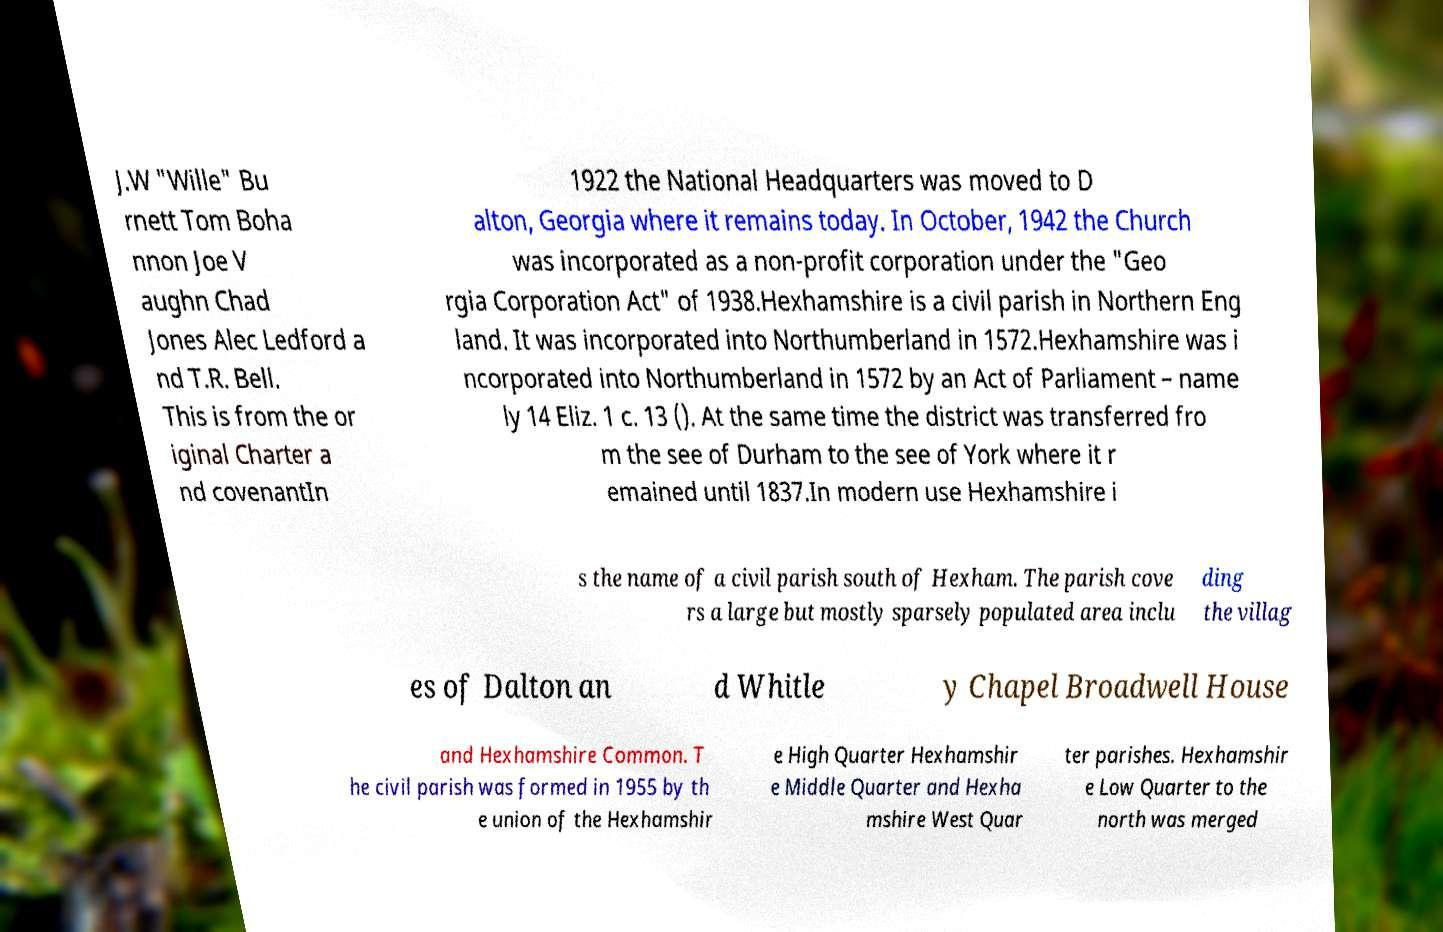Can you read and provide the text displayed in the image?This photo seems to have some interesting text. Can you extract and type it out for me? J.W "Wille" Bu rnett Tom Boha nnon Joe V aughn Chad Jones Alec Ledford a nd T.R. Bell. This is from the or iginal Charter a nd covenantIn 1922 the National Headquarters was moved to D alton, Georgia where it remains today. In October, 1942 the Church was incorporated as a non-profit corporation under the "Geo rgia Corporation Act" of 1938.Hexhamshire is a civil parish in Northern Eng land. It was incorporated into Northumberland in 1572.Hexhamshire was i ncorporated into Northumberland in 1572 by an Act of Parliament – name ly 14 Eliz. 1 c. 13 (). At the same time the district was transferred fro m the see of Durham to the see of York where it r emained until 1837.In modern use Hexhamshire i s the name of a civil parish south of Hexham. The parish cove rs a large but mostly sparsely populated area inclu ding the villag es of Dalton an d Whitle y Chapel Broadwell House and Hexhamshire Common. T he civil parish was formed in 1955 by th e union of the Hexhamshir e High Quarter Hexhamshir e Middle Quarter and Hexha mshire West Quar ter parishes. Hexhamshir e Low Quarter to the north was merged 